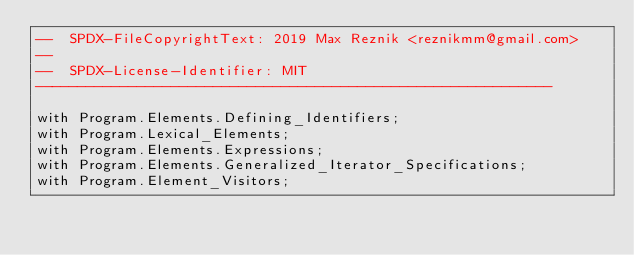Convert code to text. <code><loc_0><loc_0><loc_500><loc_500><_Ada_>--  SPDX-FileCopyrightText: 2019 Max Reznik <reznikmm@gmail.com>
--
--  SPDX-License-Identifier: MIT
-------------------------------------------------------------

with Program.Elements.Defining_Identifiers;
with Program.Lexical_Elements;
with Program.Elements.Expressions;
with Program.Elements.Generalized_Iterator_Specifications;
with Program.Element_Visitors;
</code> 